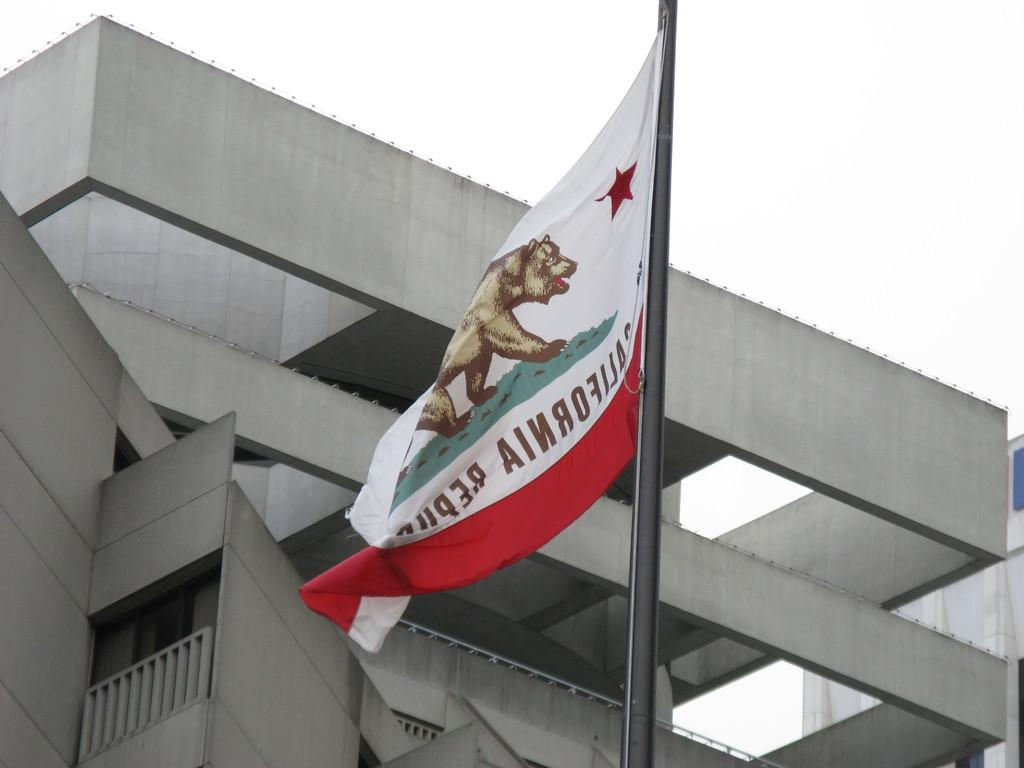What is the main subject in the center of the image? There is a flag in the center of the image. What can be seen in the background of the image? There are buildings in the background of the image. What type of calculator is being used by the person in the image? There is no person or calculator present in the image; it only features a flag and buildings in the background. 